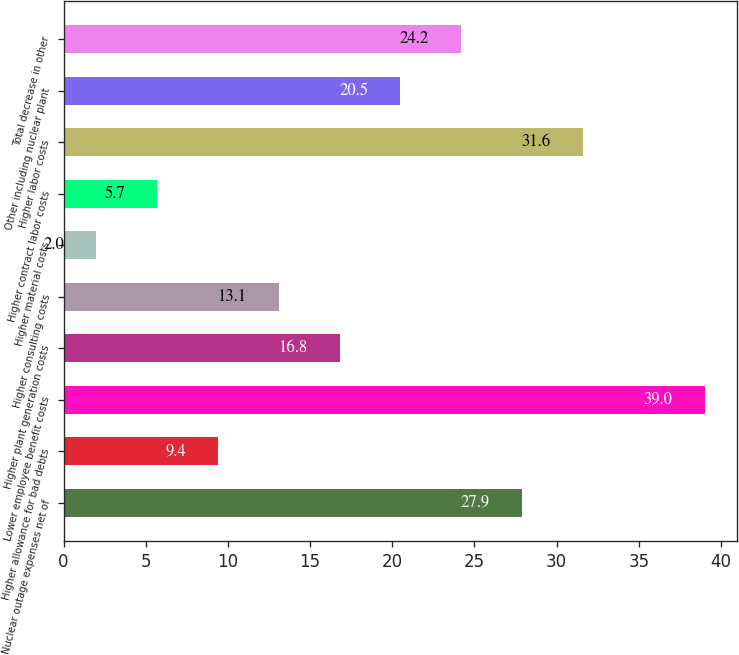Convert chart to OTSL. <chart><loc_0><loc_0><loc_500><loc_500><bar_chart><fcel>Nuclear outage expenses net of<fcel>Higher allowance for bad debts<fcel>Lower employee benefit costs<fcel>Higher plant generation costs<fcel>Higher consulting costs<fcel>Higher material costs<fcel>Higher contract labor costs<fcel>Higher labor costs<fcel>Other including nuclear plant<fcel>Total decrease in other<nl><fcel>27.9<fcel>9.4<fcel>39<fcel>16.8<fcel>13.1<fcel>2<fcel>5.7<fcel>31.6<fcel>20.5<fcel>24.2<nl></chart> 